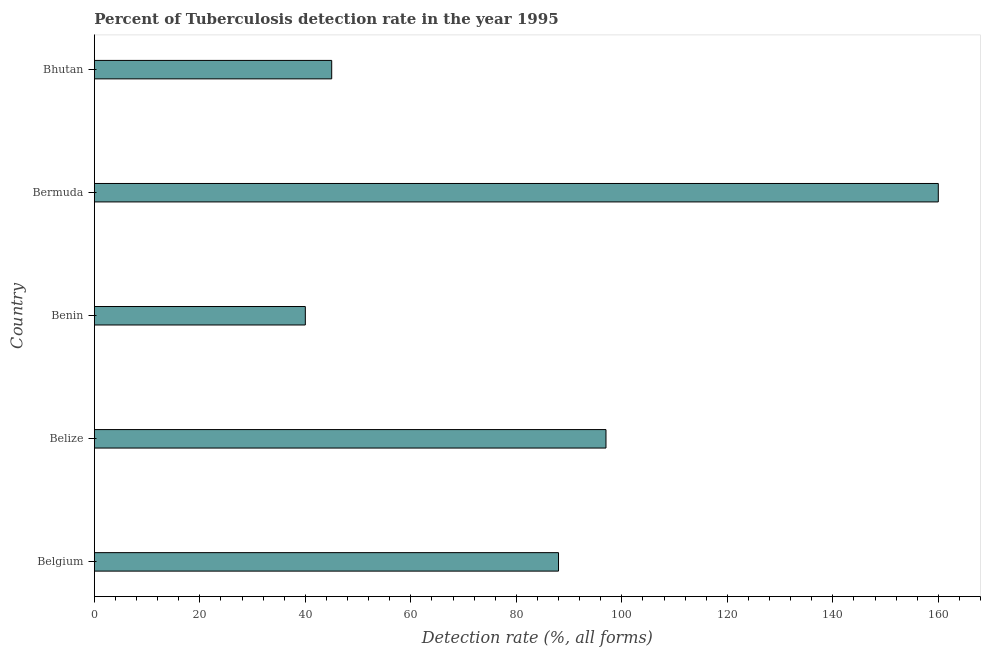What is the title of the graph?
Provide a succinct answer. Percent of Tuberculosis detection rate in the year 1995. What is the label or title of the X-axis?
Your response must be concise. Detection rate (%, all forms). What is the detection rate of tuberculosis in Benin?
Your answer should be compact. 40. Across all countries, what is the maximum detection rate of tuberculosis?
Offer a terse response. 160. In which country was the detection rate of tuberculosis maximum?
Offer a terse response. Bermuda. In which country was the detection rate of tuberculosis minimum?
Offer a very short reply. Benin. What is the sum of the detection rate of tuberculosis?
Give a very brief answer. 430. What is the difference between the detection rate of tuberculosis in Belize and Bermuda?
Give a very brief answer. -63. What is the average detection rate of tuberculosis per country?
Your answer should be very brief. 86. What is the ratio of the detection rate of tuberculosis in Belgium to that in Bhutan?
Your answer should be very brief. 1.96. Is the difference between the detection rate of tuberculosis in Benin and Bermuda greater than the difference between any two countries?
Provide a succinct answer. Yes. What is the difference between the highest and the second highest detection rate of tuberculosis?
Make the answer very short. 63. What is the difference between the highest and the lowest detection rate of tuberculosis?
Your answer should be very brief. 120. How many bars are there?
Your answer should be very brief. 5. Are all the bars in the graph horizontal?
Keep it short and to the point. Yes. What is the difference between two consecutive major ticks on the X-axis?
Provide a succinct answer. 20. Are the values on the major ticks of X-axis written in scientific E-notation?
Give a very brief answer. No. What is the Detection rate (%, all forms) in Belize?
Ensure brevity in your answer.  97. What is the Detection rate (%, all forms) of Bermuda?
Offer a very short reply. 160. What is the difference between the Detection rate (%, all forms) in Belgium and Belize?
Your answer should be compact. -9. What is the difference between the Detection rate (%, all forms) in Belgium and Benin?
Give a very brief answer. 48. What is the difference between the Detection rate (%, all forms) in Belgium and Bermuda?
Your answer should be compact. -72. What is the difference between the Detection rate (%, all forms) in Belize and Bermuda?
Make the answer very short. -63. What is the difference between the Detection rate (%, all forms) in Benin and Bermuda?
Offer a terse response. -120. What is the difference between the Detection rate (%, all forms) in Benin and Bhutan?
Keep it short and to the point. -5. What is the difference between the Detection rate (%, all forms) in Bermuda and Bhutan?
Offer a very short reply. 115. What is the ratio of the Detection rate (%, all forms) in Belgium to that in Belize?
Provide a succinct answer. 0.91. What is the ratio of the Detection rate (%, all forms) in Belgium to that in Bermuda?
Your answer should be very brief. 0.55. What is the ratio of the Detection rate (%, all forms) in Belgium to that in Bhutan?
Your answer should be very brief. 1.96. What is the ratio of the Detection rate (%, all forms) in Belize to that in Benin?
Keep it short and to the point. 2.42. What is the ratio of the Detection rate (%, all forms) in Belize to that in Bermuda?
Your answer should be very brief. 0.61. What is the ratio of the Detection rate (%, all forms) in Belize to that in Bhutan?
Make the answer very short. 2.16. What is the ratio of the Detection rate (%, all forms) in Benin to that in Bermuda?
Offer a very short reply. 0.25. What is the ratio of the Detection rate (%, all forms) in Benin to that in Bhutan?
Give a very brief answer. 0.89. What is the ratio of the Detection rate (%, all forms) in Bermuda to that in Bhutan?
Keep it short and to the point. 3.56. 